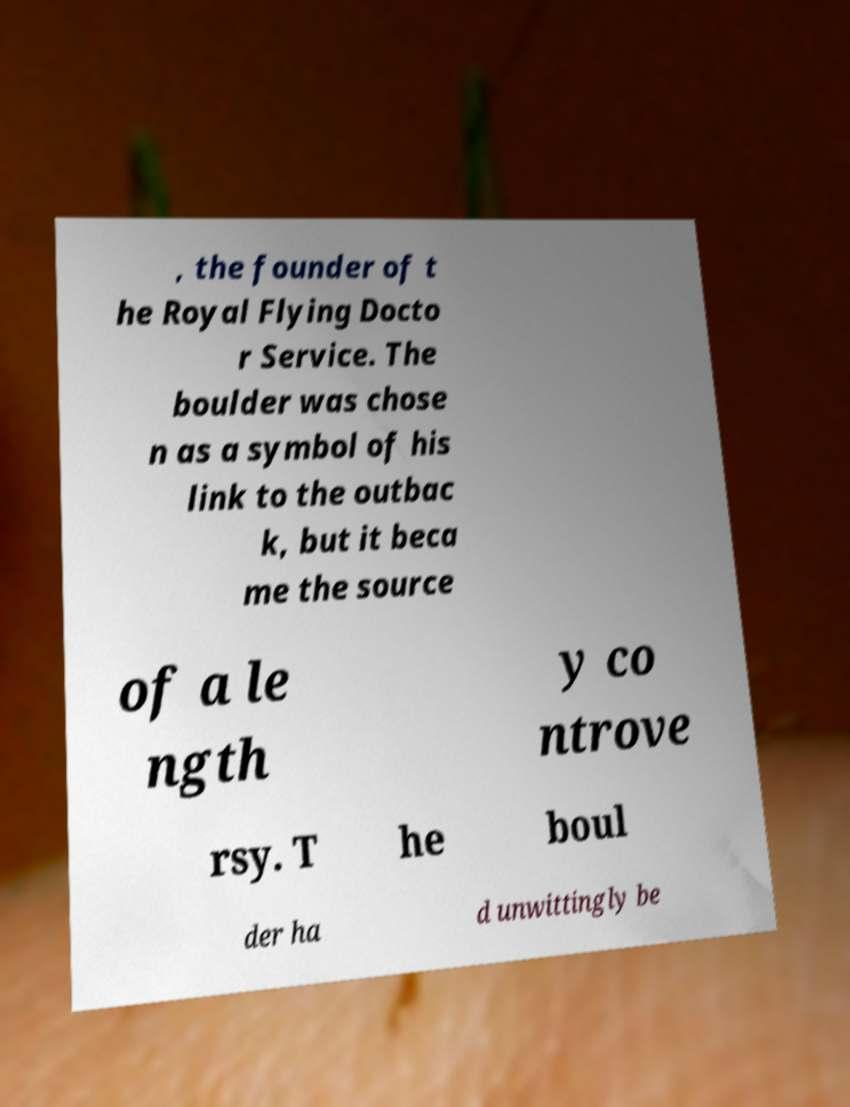I need the written content from this picture converted into text. Can you do that? , the founder of t he Royal Flying Docto r Service. The boulder was chose n as a symbol of his link to the outbac k, but it beca me the source of a le ngth y co ntrove rsy. T he boul der ha d unwittingly be 